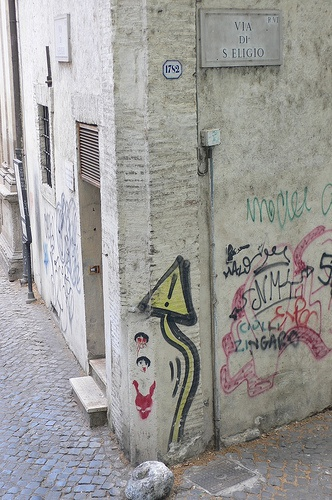Describe the objects in this image and their specific colors. I can see various objects in this image with different colors. 